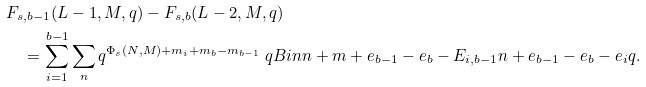<formula> <loc_0><loc_0><loc_500><loc_500>& F _ { s , b - 1 } ( L - 1 , M , q ) - F _ { s , b } ( L - 2 , M , q ) \\ & \quad = \sum _ { i = 1 } ^ { b - 1 } \sum _ { n } q ^ { \Phi _ { s } ( N , M ) + m _ { i } + m _ { b } - m _ { b - 1 } } \ q B i n { n + m + e _ { b - 1 } - e _ { b } - E _ { i , b - 1 } } { n + e _ { b - 1 } - e _ { b } - e _ { i } } { q } .</formula> 